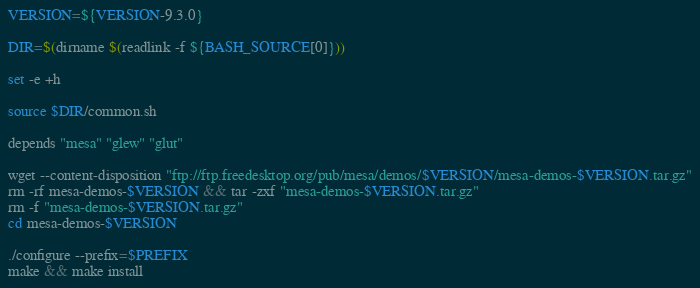Convert code to text. <code><loc_0><loc_0><loc_500><loc_500><_Bash_>VERSION=${VERSION-9.3.0}

DIR=$(dirname $(readlink -f ${BASH_SOURCE[0]}))

set -e +h

source $DIR/common.sh

depends "mesa" "glew" "glut"

wget --content-disposition "ftp://ftp.freedesktop.org/pub/mesa/demos/$VERSION/mesa-demos-$VERSION.tar.gz"
rm -rf mesa-demos-$VERSION && tar -zxf "mesa-demos-$VERSION.tar.gz"
rm -f "mesa-demos-$VERSION.tar.gz"
cd mesa-demos-$VERSION

./configure --prefix=$PREFIX
make && make install
</code> 